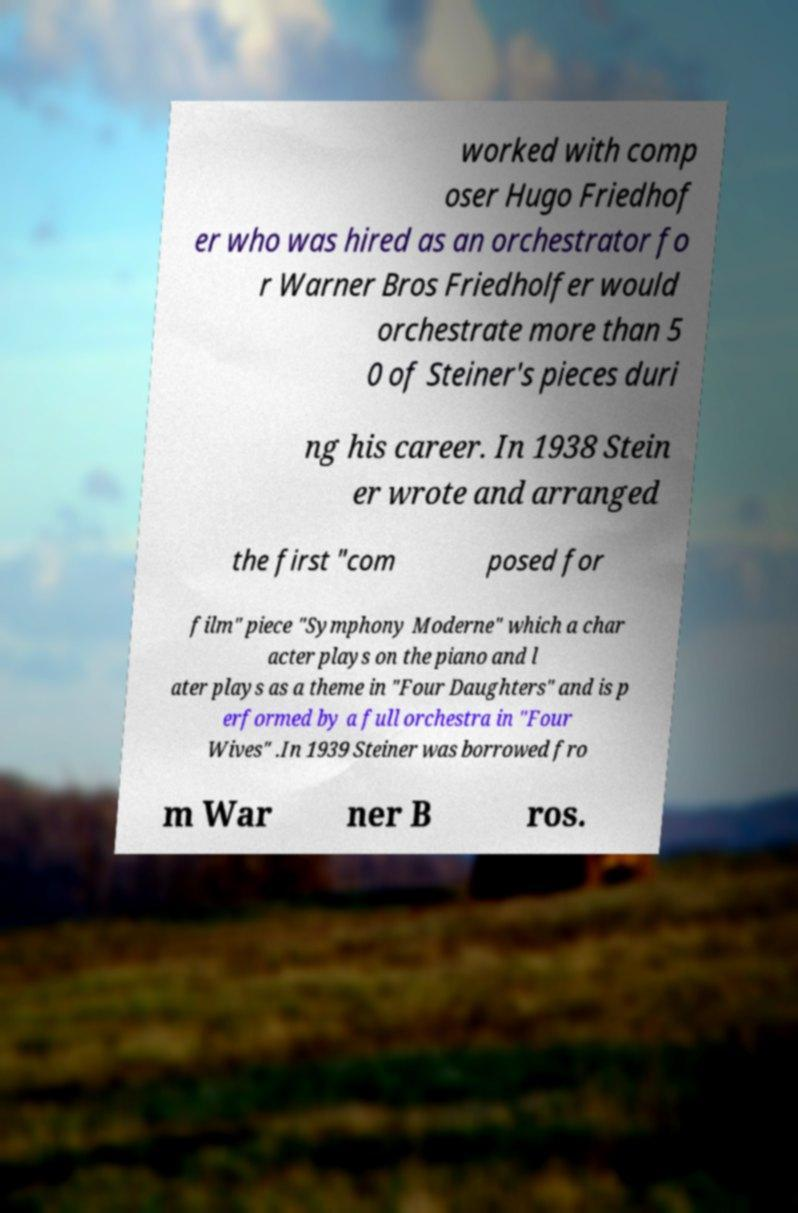I need the written content from this picture converted into text. Can you do that? worked with comp oser Hugo Friedhof er who was hired as an orchestrator fo r Warner Bros Friedholfer would orchestrate more than 5 0 of Steiner's pieces duri ng his career. In 1938 Stein er wrote and arranged the first "com posed for film" piece "Symphony Moderne" which a char acter plays on the piano and l ater plays as a theme in "Four Daughters" and is p erformed by a full orchestra in "Four Wives" .In 1939 Steiner was borrowed fro m War ner B ros. 